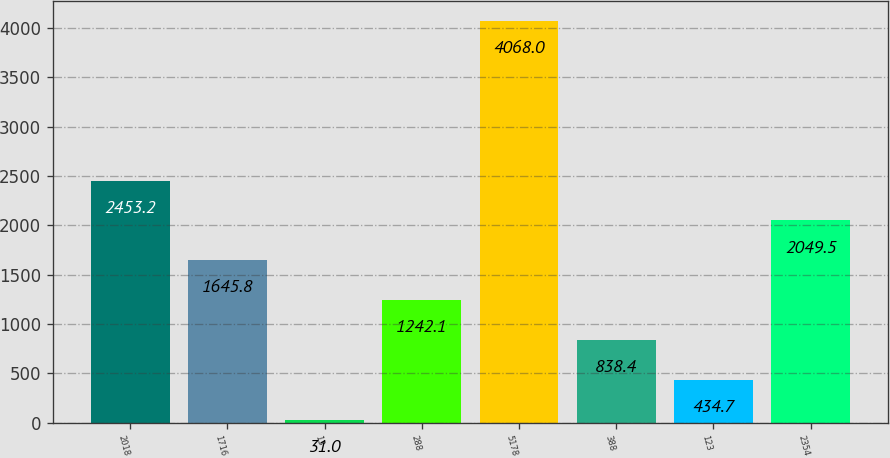<chart> <loc_0><loc_0><loc_500><loc_500><bar_chart><fcel>2018<fcel>1716<fcel>13<fcel>288<fcel>5178<fcel>388<fcel>123<fcel>2354<nl><fcel>2453.2<fcel>1645.8<fcel>31<fcel>1242.1<fcel>4068<fcel>838.4<fcel>434.7<fcel>2049.5<nl></chart> 